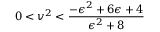Convert formula to latex. <formula><loc_0><loc_0><loc_500><loc_500>0 < v ^ { 2 } < \frac { - \epsilon ^ { 2 } + 6 \epsilon + 4 } { \epsilon ^ { 2 } + 8 }</formula> 